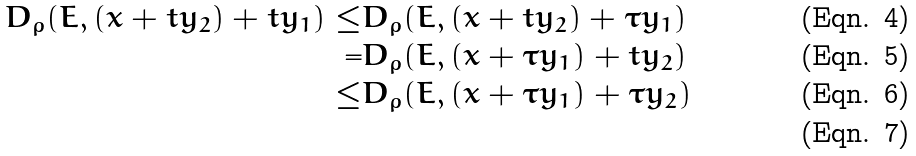Convert formula to latex. <formula><loc_0><loc_0><loc_500><loc_500>D _ { \rho } ( E , ( x + t y _ { 2 } ) + t y _ { 1 } ) \leq & D _ { \rho } ( E , ( x + t y _ { 2 } ) + \tau y _ { 1 } ) \\ = & D _ { \rho } ( E , ( x + \tau y _ { 1 } ) + t y _ { 2 } ) \\ \leq & D _ { \rho } ( E , ( x + \tau y _ { 1 } ) + \tau y _ { 2 } ) \\</formula> 